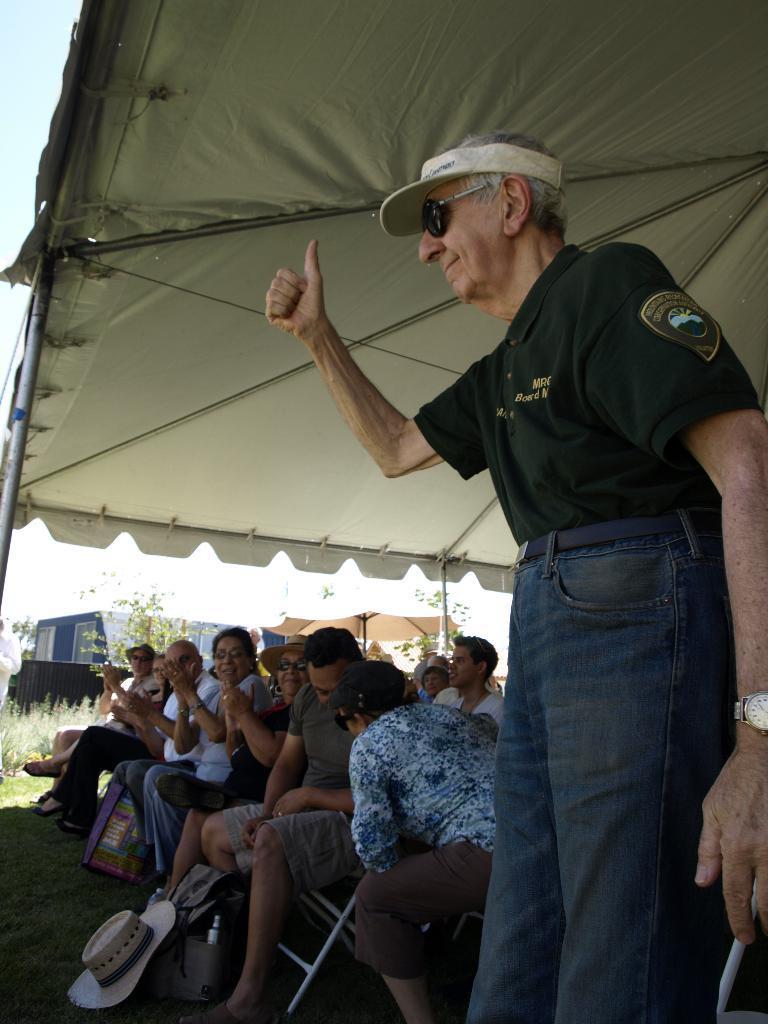How would you summarize this image in a sentence or two? On the right side, there is a person in a black color T-shirt, showing his thumb, smiling and standing. In the background, there are other persons, sitting on chairs under a tent, there is another tent, there is a building, there are trees and grass on the ground and there are clouds in the sky. 